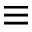Convert formula to latex. <formula><loc_0><loc_0><loc_500><loc_500>\equiv</formula> 